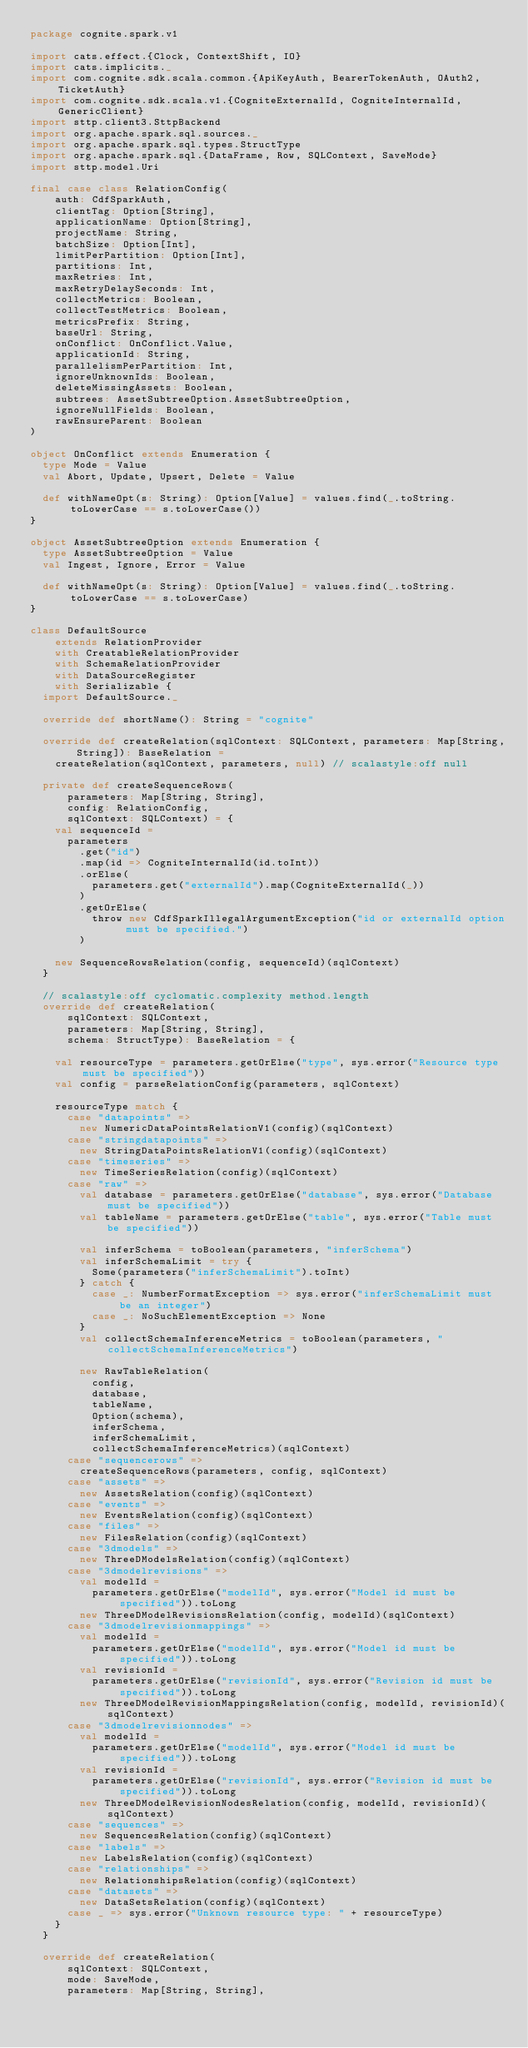Convert code to text. <code><loc_0><loc_0><loc_500><loc_500><_Scala_>package cognite.spark.v1

import cats.effect.{Clock, ContextShift, IO}
import cats.implicits._
import com.cognite.sdk.scala.common.{ApiKeyAuth, BearerTokenAuth, OAuth2, TicketAuth}
import com.cognite.sdk.scala.v1.{CogniteExternalId, CogniteInternalId, GenericClient}
import sttp.client3.SttpBackend
import org.apache.spark.sql.sources._
import org.apache.spark.sql.types.StructType
import org.apache.spark.sql.{DataFrame, Row, SQLContext, SaveMode}
import sttp.model.Uri

final case class RelationConfig(
    auth: CdfSparkAuth,
    clientTag: Option[String],
    applicationName: Option[String],
    projectName: String,
    batchSize: Option[Int],
    limitPerPartition: Option[Int],
    partitions: Int,
    maxRetries: Int,
    maxRetryDelaySeconds: Int,
    collectMetrics: Boolean,
    collectTestMetrics: Boolean,
    metricsPrefix: String,
    baseUrl: String,
    onConflict: OnConflict.Value,
    applicationId: String,
    parallelismPerPartition: Int,
    ignoreUnknownIds: Boolean,
    deleteMissingAssets: Boolean,
    subtrees: AssetSubtreeOption.AssetSubtreeOption,
    ignoreNullFields: Boolean,
    rawEnsureParent: Boolean
)

object OnConflict extends Enumeration {
  type Mode = Value
  val Abort, Update, Upsert, Delete = Value

  def withNameOpt(s: String): Option[Value] = values.find(_.toString.toLowerCase == s.toLowerCase())
}

object AssetSubtreeOption extends Enumeration {
  type AssetSubtreeOption = Value
  val Ingest, Ignore, Error = Value

  def withNameOpt(s: String): Option[Value] = values.find(_.toString.toLowerCase == s.toLowerCase)
}

class DefaultSource
    extends RelationProvider
    with CreatableRelationProvider
    with SchemaRelationProvider
    with DataSourceRegister
    with Serializable {
  import DefaultSource._

  override def shortName(): String = "cognite"

  override def createRelation(sqlContext: SQLContext, parameters: Map[String, String]): BaseRelation =
    createRelation(sqlContext, parameters, null) // scalastyle:off null

  private def createSequenceRows(
      parameters: Map[String, String],
      config: RelationConfig,
      sqlContext: SQLContext) = {
    val sequenceId =
      parameters
        .get("id")
        .map(id => CogniteInternalId(id.toInt))
        .orElse(
          parameters.get("externalId").map(CogniteExternalId(_))
        )
        .getOrElse(
          throw new CdfSparkIllegalArgumentException("id or externalId option must be specified.")
        )

    new SequenceRowsRelation(config, sequenceId)(sqlContext)
  }

  // scalastyle:off cyclomatic.complexity method.length
  override def createRelation(
      sqlContext: SQLContext,
      parameters: Map[String, String],
      schema: StructType): BaseRelation = {

    val resourceType = parameters.getOrElse("type", sys.error("Resource type must be specified"))
    val config = parseRelationConfig(parameters, sqlContext)

    resourceType match {
      case "datapoints" =>
        new NumericDataPointsRelationV1(config)(sqlContext)
      case "stringdatapoints" =>
        new StringDataPointsRelationV1(config)(sqlContext)
      case "timeseries" =>
        new TimeSeriesRelation(config)(sqlContext)
      case "raw" =>
        val database = parameters.getOrElse("database", sys.error("Database must be specified"))
        val tableName = parameters.getOrElse("table", sys.error("Table must be specified"))

        val inferSchema = toBoolean(parameters, "inferSchema")
        val inferSchemaLimit = try {
          Some(parameters("inferSchemaLimit").toInt)
        } catch {
          case _: NumberFormatException => sys.error("inferSchemaLimit must be an integer")
          case _: NoSuchElementException => None
        }
        val collectSchemaInferenceMetrics = toBoolean(parameters, "collectSchemaInferenceMetrics")

        new RawTableRelation(
          config,
          database,
          tableName,
          Option(schema),
          inferSchema,
          inferSchemaLimit,
          collectSchemaInferenceMetrics)(sqlContext)
      case "sequencerows" =>
        createSequenceRows(parameters, config, sqlContext)
      case "assets" =>
        new AssetsRelation(config)(sqlContext)
      case "events" =>
        new EventsRelation(config)(sqlContext)
      case "files" =>
        new FilesRelation(config)(sqlContext)
      case "3dmodels" =>
        new ThreeDModelsRelation(config)(sqlContext)
      case "3dmodelrevisions" =>
        val modelId =
          parameters.getOrElse("modelId", sys.error("Model id must be specified")).toLong
        new ThreeDModelRevisionsRelation(config, modelId)(sqlContext)
      case "3dmodelrevisionmappings" =>
        val modelId =
          parameters.getOrElse("modelId", sys.error("Model id must be specified")).toLong
        val revisionId =
          parameters.getOrElse("revisionId", sys.error("Revision id must be specified")).toLong
        new ThreeDModelRevisionMappingsRelation(config, modelId, revisionId)(sqlContext)
      case "3dmodelrevisionnodes" =>
        val modelId =
          parameters.getOrElse("modelId", sys.error("Model id must be specified")).toLong
        val revisionId =
          parameters.getOrElse("revisionId", sys.error("Revision id must be specified")).toLong
        new ThreeDModelRevisionNodesRelation(config, modelId, revisionId)(sqlContext)
      case "sequences" =>
        new SequencesRelation(config)(sqlContext)
      case "labels" =>
        new LabelsRelation(config)(sqlContext)
      case "relationships" =>
        new RelationshipsRelation(config)(sqlContext)
      case "datasets" =>
        new DataSetsRelation(config)(sqlContext)
      case _ => sys.error("Unknown resource type: " + resourceType)
    }
  }

  override def createRelation(
      sqlContext: SQLContext,
      mode: SaveMode,
      parameters: Map[String, String],</code> 